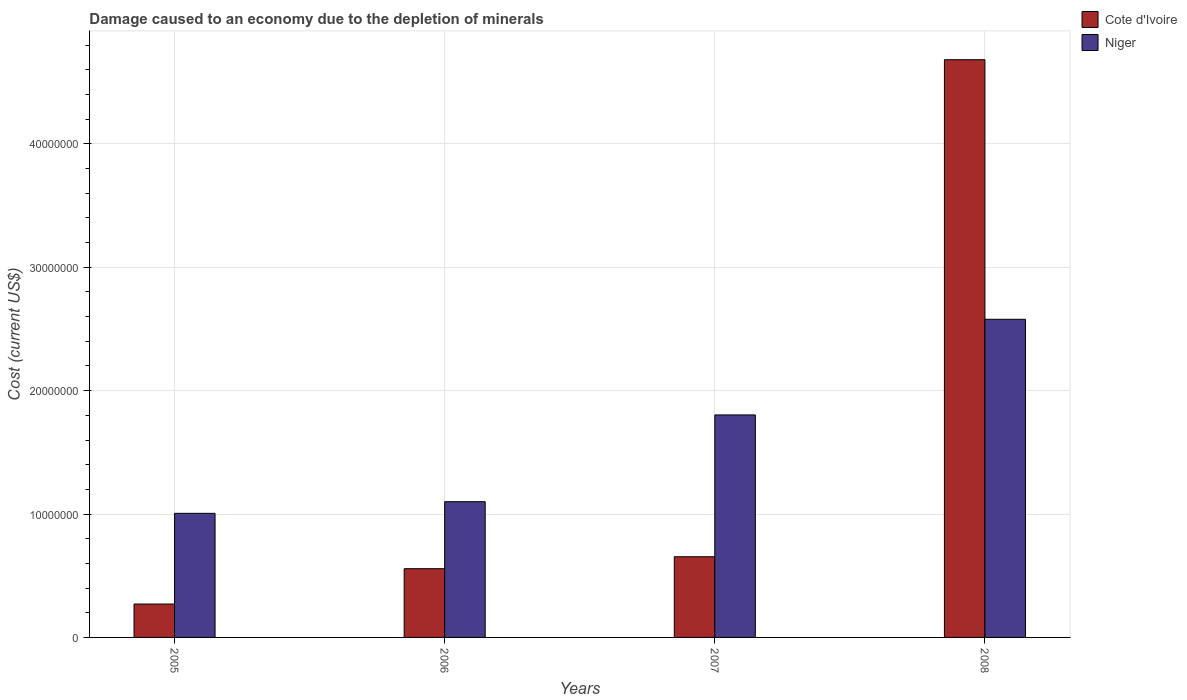How many different coloured bars are there?
Your answer should be very brief. 2. Are the number of bars on each tick of the X-axis equal?
Your answer should be very brief. Yes. How many bars are there on the 4th tick from the left?
Your answer should be compact. 2. How many bars are there on the 4th tick from the right?
Give a very brief answer. 2. What is the label of the 3rd group of bars from the left?
Give a very brief answer. 2007. What is the cost of damage caused due to the depletion of minerals in Niger in 2007?
Keep it short and to the point. 1.80e+07. Across all years, what is the maximum cost of damage caused due to the depletion of minerals in Cote d'Ivoire?
Provide a short and direct response. 4.68e+07. Across all years, what is the minimum cost of damage caused due to the depletion of minerals in Niger?
Provide a short and direct response. 1.01e+07. What is the total cost of damage caused due to the depletion of minerals in Cote d'Ivoire in the graph?
Offer a very short reply. 6.16e+07. What is the difference between the cost of damage caused due to the depletion of minerals in Cote d'Ivoire in 2005 and that in 2007?
Offer a terse response. -3.83e+06. What is the difference between the cost of damage caused due to the depletion of minerals in Niger in 2008 and the cost of damage caused due to the depletion of minerals in Cote d'Ivoire in 2006?
Ensure brevity in your answer.  2.02e+07. What is the average cost of damage caused due to the depletion of minerals in Niger per year?
Your response must be concise. 1.62e+07. In the year 2006, what is the difference between the cost of damage caused due to the depletion of minerals in Cote d'Ivoire and cost of damage caused due to the depletion of minerals in Niger?
Keep it short and to the point. -5.43e+06. In how many years, is the cost of damage caused due to the depletion of minerals in Niger greater than 22000000 US$?
Provide a short and direct response. 1. What is the ratio of the cost of damage caused due to the depletion of minerals in Cote d'Ivoire in 2005 to that in 2007?
Ensure brevity in your answer.  0.41. What is the difference between the highest and the second highest cost of damage caused due to the depletion of minerals in Cote d'Ivoire?
Ensure brevity in your answer.  4.03e+07. What is the difference between the highest and the lowest cost of damage caused due to the depletion of minerals in Cote d'Ivoire?
Your response must be concise. 4.41e+07. What does the 1st bar from the left in 2006 represents?
Give a very brief answer. Cote d'Ivoire. What does the 1st bar from the right in 2006 represents?
Give a very brief answer. Niger. How many bars are there?
Your answer should be very brief. 8. Are all the bars in the graph horizontal?
Ensure brevity in your answer.  No. How many years are there in the graph?
Make the answer very short. 4. Are the values on the major ticks of Y-axis written in scientific E-notation?
Make the answer very short. No. Does the graph contain any zero values?
Your answer should be compact. No. Does the graph contain grids?
Provide a short and direct response. Yes. How many legend labels are there?
Your response must be concise. 2. How are the legend labels stacked?
Offer a terse response. Vertical. What is the title of the graph?
Offer a terse response. Damage caused to an economy due to the depletion of minerals. Does "Turkey" appear as one of the legend labels in the graph?
Keep it short and to the point. No. What is the label or title of the Y-axis?
Offer a terse response. Cost (current US$). What is the Cost (current US$) of Cote d'Ivoire in 2005?
Ensure brevity in your answer.  2.71e+06. What is the Cost (current US$) of Niger in 2005?
Ensure brevity in your answer.  1.01e+07. What is the Cost (current US$) of Cote d'Ivoire in 2006?
Provide a short and direct response. 5.57e+06. What is the Cost (current US$) of Niger in 2006?
Give a very brief answer. 1.10e+07. What is the Cost (current US$) of Cote d'Ivoire in 2007?
Provide a short and direct response. 6.54e+06. What is the Cost (current US$) in Niger in 2007?
Provide a short and direct response. 1.80e+07. What is the Cost (current US$) of Cote d'Ivoire in 2008?
Offer a very short reply. 4.68e+07. What is the Cost (current US$) of Niger in 2008?
Provide a succinct answer. 2.58e+07. Across all years, what is the maximum Cost (current US$) of Cote d'Ivoire?
Your response must be concise. 4.68e+07. Across all years, what is the maximum Cost (current US$) of Niger?
Your answer should be compact. 2.58e+07. Across all years, what is the minimum Cost (current US$) of Cote d'Ivoire?
Make the answer very short. 2.71e+06. Across all years, what is the minimum Cost (current US$) of Niger?
Make the answer very short. 1.01e+07. What is the total Cost (current US$) in Cote d'Ivoire in the graph?
Offer a terse response. 6.16e+07. What is the total Cost (current US$) in Niger in the graph?
Your answer should be very brief. 6.49e+07. What is the difference between the Cost (current US$) in Cote d'Ivoire in 2005 and that in 2006?
Make the answer very short. -2.86e+06. What is the difference between the Cost (current US$) of Niger in 2005 and that in 2006?
Make the answer very short. -9.46e+05. What is the difference between the Cost (current US$) of Cote d'Ivoire in 2005 and that in 2007?
Offer a very short reply. -3.83e+06. What is the difference between the Cost (current US$) of Niger in 2005 and that in 2007?
Provide a short and direct response. -7.98e+06. What is the difference between the Cost (current US$) in Cote d'Ivoire in 2005 and that in 2008?
Offer a very short reply. -4.41e+07. What is the difference between the Cost (current US$) in Niger in 2005 and that in 2008?
Ensure brevity in your answer.  -1.57e+07. What is the difference between the Cost (current US$) in Cote d'Ivoire in 2006 and that in 2007?
Provide a succinct answer. -9.69e+05. What is the difference between the Cost (current US$) in Niger in 2006 and that in 2007?
Keep it short and to the point. -7.03e+06. What is the difference between the Cost (current US$) in Cote d'Ivoire in 2006 and that in 2008?
Ensure brevity in your answer.  -4.13e+07. What is the difference between the Cost (current US$) of Niger in 2006 and that in 2008?
Provide a succinct answer. -1.48e+07. What is the difference between the Cost (current US$) in Cote d'Ivoire in 2007 and that in 2008?
Your answer should be very brief. -4.03e+07. What is the difference between the Cost (current US$) of Niger in 2007 and that in 2008?
Your response must be concise. -7.75e+06. What is the difference between the Cost (current US$) of Cote d'Ivoire in 2005 and the Cost (current US$) of Niger in 2006?
Provide a succinct answer. -8.30e+06. What is the difference between the Cost (current US$) of Cote d'Ivoire in 2005 and the Cost (current US$) of Niger in 2007?
Make the answer very short. -1.53e+07. What is the difference between the Cost (current US$) of Cote d'Ivoire in 2005 and the Cost (current US$) of Niger in 2008?
Keep it short and to the point. -2.31e+07. What is the difference between the Cost (current US$) of Cote d'Ivoire in 2006 and the Cost (current US$) of Niger in 2007?
Give a very brief answer. -1.25e+07. What is the difference between the Cost (current US$) of Cote d'Ivoire in 2006 and the Cost (current US$) of Niger in 2008?
Keep it short and to the point. -2.02e+07. What is the difference between the Cost (current US$) of Cote d'Ivoire in 2007 and the Cost (current US$) of Niger in 2008?
Provide a short and direct response. -1.92e+07. What is the average Cost (current US$) in Cote d'Ivoire per year?
Offer a terse response. 1.54e+07. What is the average Cost (current US$) of Niger per year?
Your answer should be very brief. 1.62e+07. In the year 2005, what is the difference between the Cost (current US$) of Cote d'Ivoire and Cost (current US$) of Niger?
Provide a succinct answer. -7.35e+06. In the year 2006, what is the difference between the Cost (current US$) of Cote d'Ivoire and Cost (current US$) of Niger?
Your answer should be compact. -5.43e+06. In the year 2007, what is the difference between the Cost (current US$) in Cote d'Ivoire and Cost (current US$) in Niger?
Provide a succinct answer. -1.15e+07. In the year 2008, what is the difference between the Cost (current US$) in Cote d'Ivoire and Cost (current US$) in Niger?
Ensure brevity in your answer.  2.10e+07. What is the ratio of the Cost (current US$) in Cote d'Ivoire in 2005 to that in 2006?
Make the answer very short. 0.49. What is the ratio of the Cost (current US$) of Niger in 2005 to that in 2006?
Ensure brevity in your answer.  0.91. What is the ratio of the Cost (current US$) of Cote d'Ivoire in 2005 to that in 2007?
Keep it short and to the point. 0.41. What is the ratio of the Cost (current US$) in Niger in 2005 to that in 2007?
Offer a very short reply. 0.56. What is the ratio of the Cost (current US$) of Cote d'Ivoire in 2005 to that in 2008?
Your response must be concise. 0.06. What is the ratio of the Cost (current US$) in Niger in 2005 to that in 2008?
Your answer should be very brief. 0.39. What is the ratio of the Cost (current US$) in Cote d'Ivoire in 2006 to that in 2007?
Your answer should be very brief. 0.85. What is the ratio of the Cost (current US$) of Niger in 2006 to that in 2007?
Your response must be concise. 0.61. What is the ratio of the Cost (current US$) of Cote d'Ivoire in 2006 to that in 2008?
Keep it short and to the point. 0.12. What is the ratio of the Cost (current US$) of Niger in 2006 to that in 2008?
Keep it short and to the point. 0.43. What is the ratio of the Cost (current US$) in Cote d'Ivoire in 2007 to that in 2008?
Your answer should be compact. 0.14. What is the ratio of the Cost (current US$) of Niger in 2007 to that in 2008?
Your answer should be compact. 0.7. What is the difference between the highest and the second highest Cost (current US$) of Cote d'Ivoire?
Your answer should be compact. 4.03e+07. What is the difference between the highest and the second highest Cost (current US$) in Niger?
Keep it short and to the point. 7.75e+06. What is the difference between the highest and the lowest Cost (current US$) of Cote d'Ivoire?
Offer a terse response. 4.41e+07. What is the difference between the highest and the lowest Cost (current US$) in Niger?
Provide a short and direct response. 1.57e+07. 